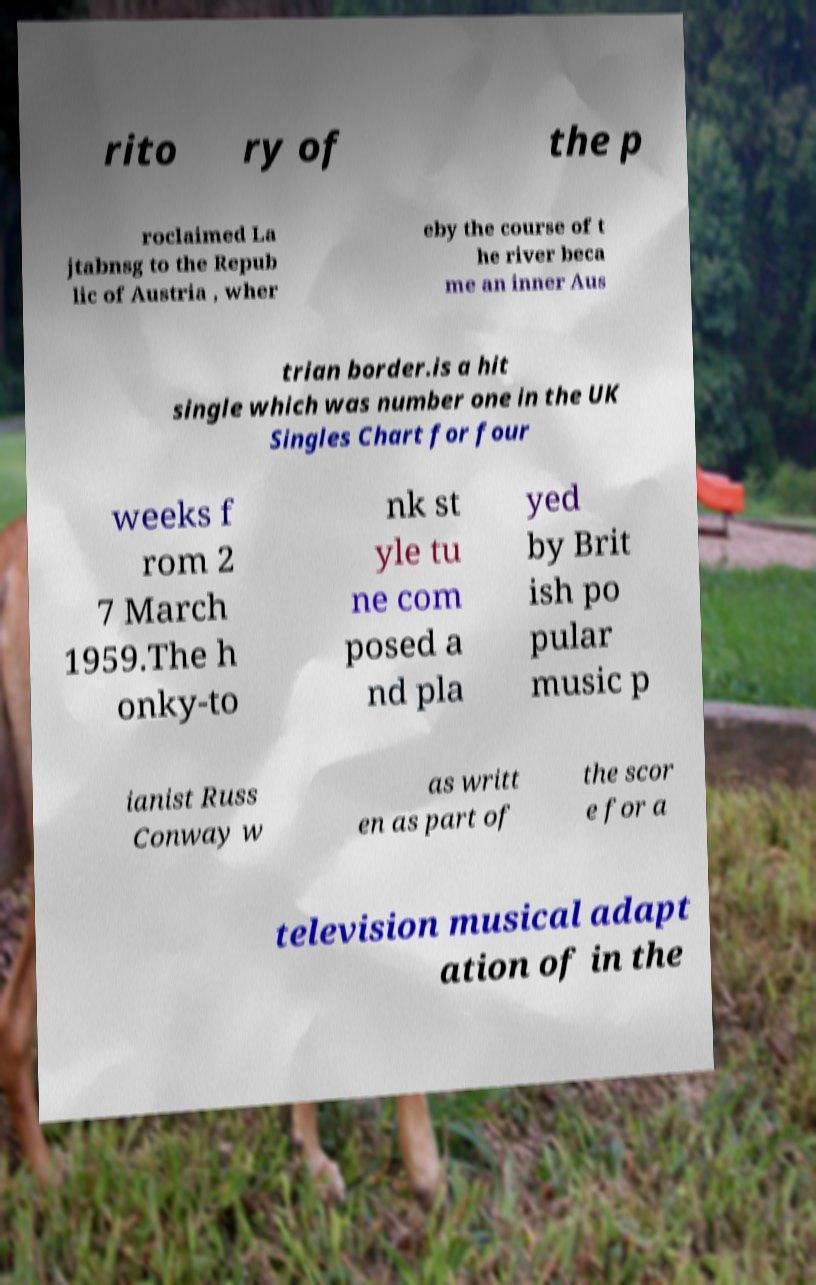What messages or text are displayed in this image? I need them in a readable, typed format. rito ry of the p roclaimed La jtabnsg to the Repub lic of Austria , wher eby the course of t he river beca me an inner Aus trian border.is a hit single which was number one in the UK Singles Chart for four weeks f rom 2 7 March 1959.The h onky-to nk st yle tu ne com posed a nd pla yed by Brit ish po pular music p ianist Russ Conway w as writt en as part of the scor e for a television musical adapt ation of in the 